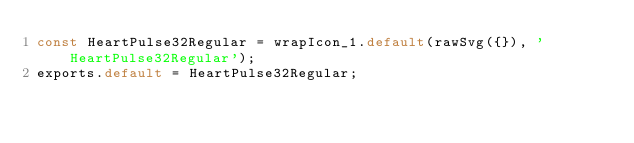<code> <loc_0><loc_0><loc_500><loc_500><_JavaScript_>const HeartPulse32Regular = wrapIcon_1.default(rawSvg({}), 'HeartPulse32Regular');
exports.default = HeartPulse32Regular;
</code> 